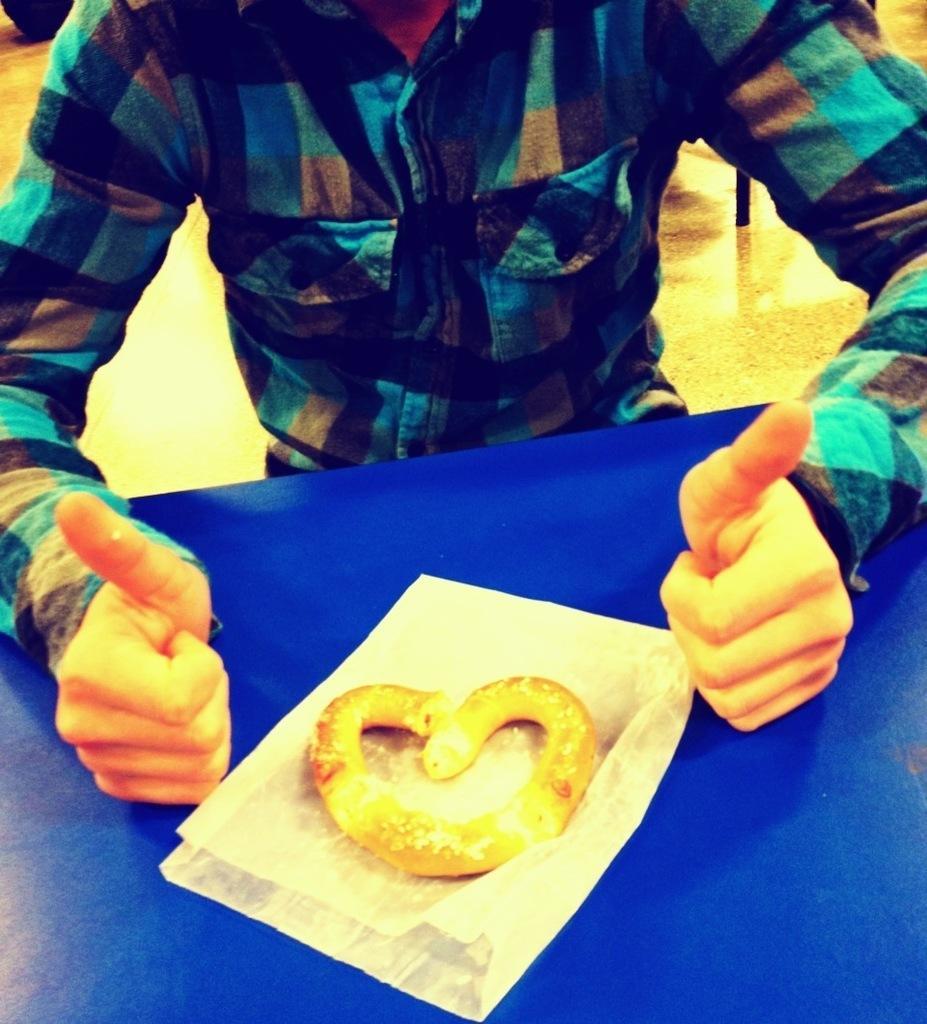Can you describe this image briefly? In the center of the image we can see a table. On the table we can see food item and paper. At the top of the image we can see floor and a person. 